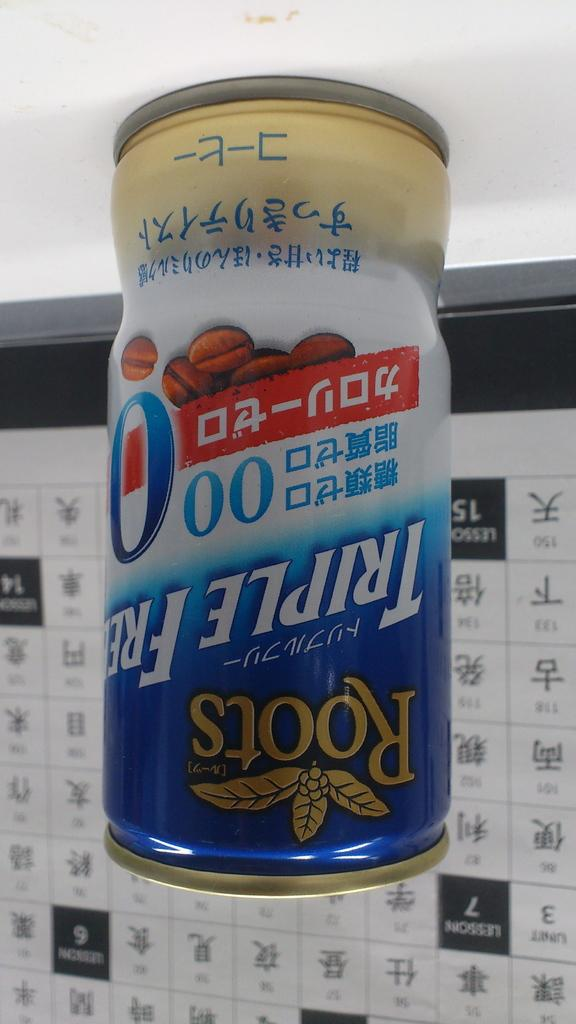<image>
Provide a brief description of the given image. An upside down can of Roots Triple Freeze 